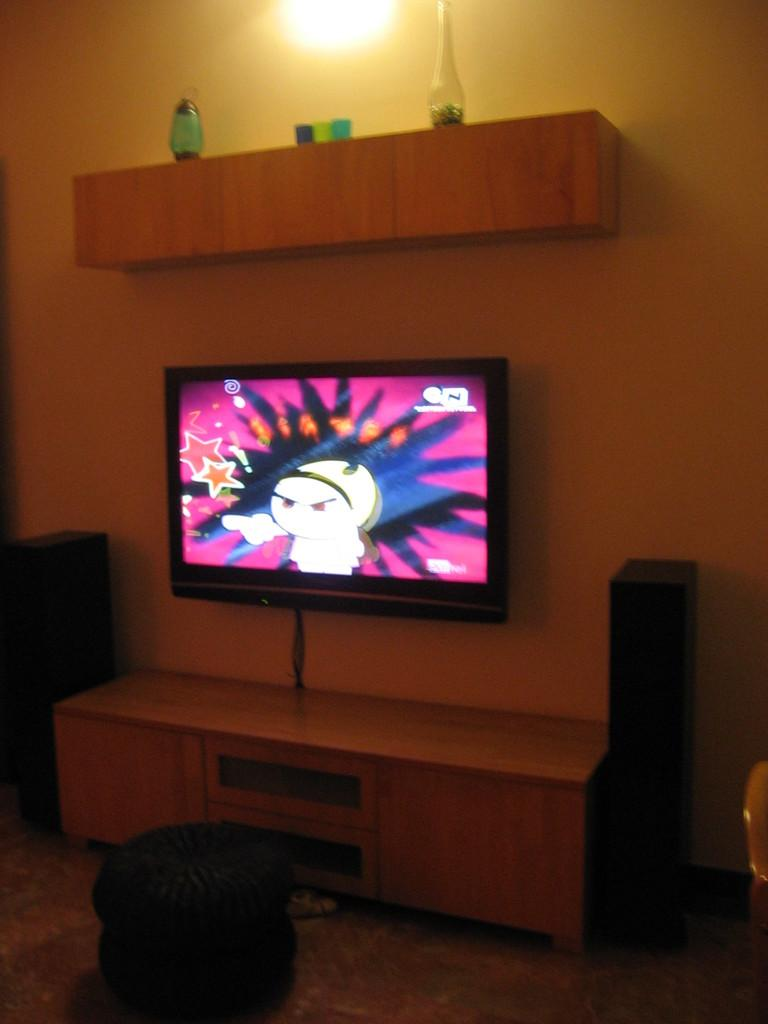What type of furniture is present in the image? There is a stool and a cupboard in the image. What electronic devices can be seen in the image? There are speakers and a television attached to the wall in the image. What is fixed to the wall in the image? There is a rack with objects on it in the image. What type of polish is being applied to the stool in the image? There is no indication in the image that any polish is being applied to the stool. How does the station affect the positioning of the cupboard in the image? There is no mention of a station in the image, and therefore it cannot affect the positioning of the cupboard. 